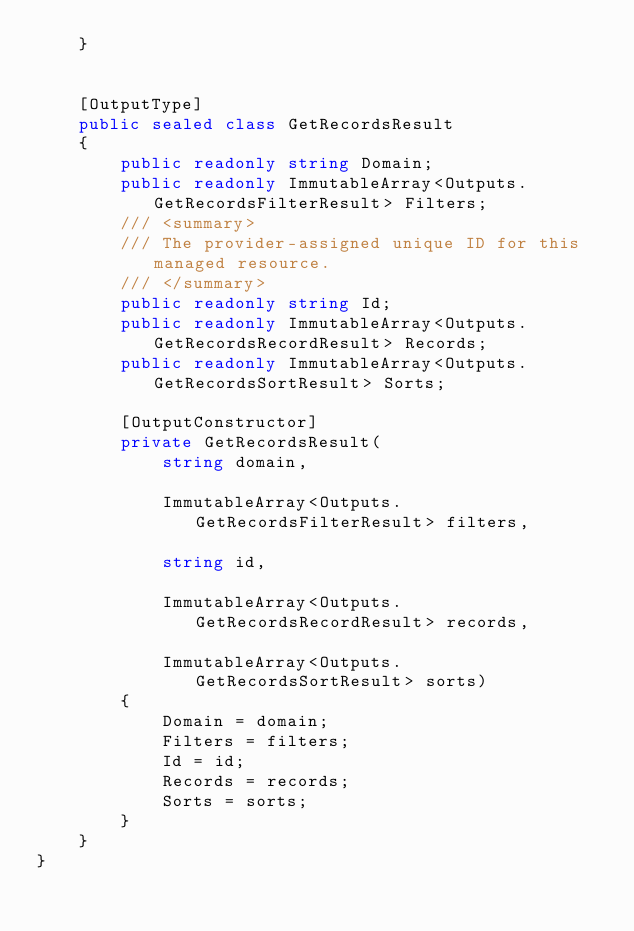Convert code to text. <code><loc_0><loc_0><loc_500><loc_500><_C#_>    }


    [OutputType]
    public sealed class GetRecordsResult
    {
        public readonly string Domain;
        public readonly ImmutableArray<Outputs.GetRecordsFilterResult> Filters;
        /// <summary>
        /// The provider-assigned unique ID for this managed resource.
        /// </summary>
        public readonly string Id;
        public readonly ImmutableArray<Outputs.GetRecordsRecordResult> Records;
        public readonly ImmutableArray<Outputs.GetRecordsSortResult> Sorts;

        [OutputConstructor]
        private GetRecordsResult(
            string domain,

            ImmutableArray<Outputs.GetRecordsFilterResult> filters,

            string id,

            ImmutableArray<Outputs.GetRecordsRecordResult> records,

            ImmutableArray<Outputs.GetRecordsSortResult> sorts)
        {
            Domain = domain;
            Filters = filters;
            Id = id;
            Records = records;
            Sorts = sorts;
        }
    }
}
</code> 